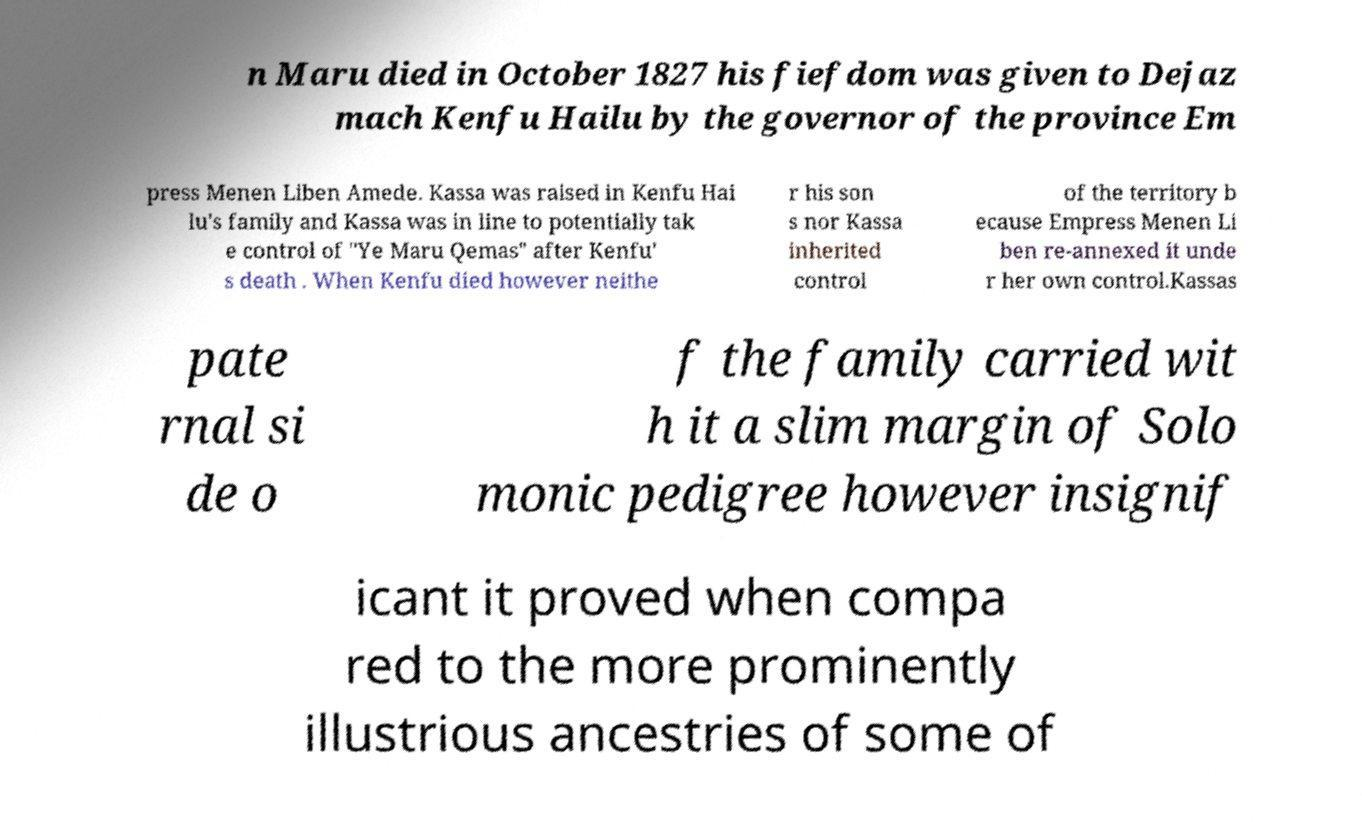Could you assist in decoding the text presented in this image and type it out clearly? n Maru died in October 1827 his fiefdom was given to Dejaz mach Kenfu Hailu by the governor of the province Em press Menen Liben Amede. Kassa was raised in Kenfu Hai lu's family and Kassa was in line to potentially tak e control of "Ye Maru Qemas" after Kenfu' s death . When Kenfu died however neithe r his son s nor Kassa inherited control of the territory b ecause Empress Menen Li ben re-annexed it unde r her own control.Kassas pate rnal si de o f the family carried wit h it a slim margin of Solo monic pedigree however insignif icant it proved when compa red to the more prominently illustrious ancestries of some of 